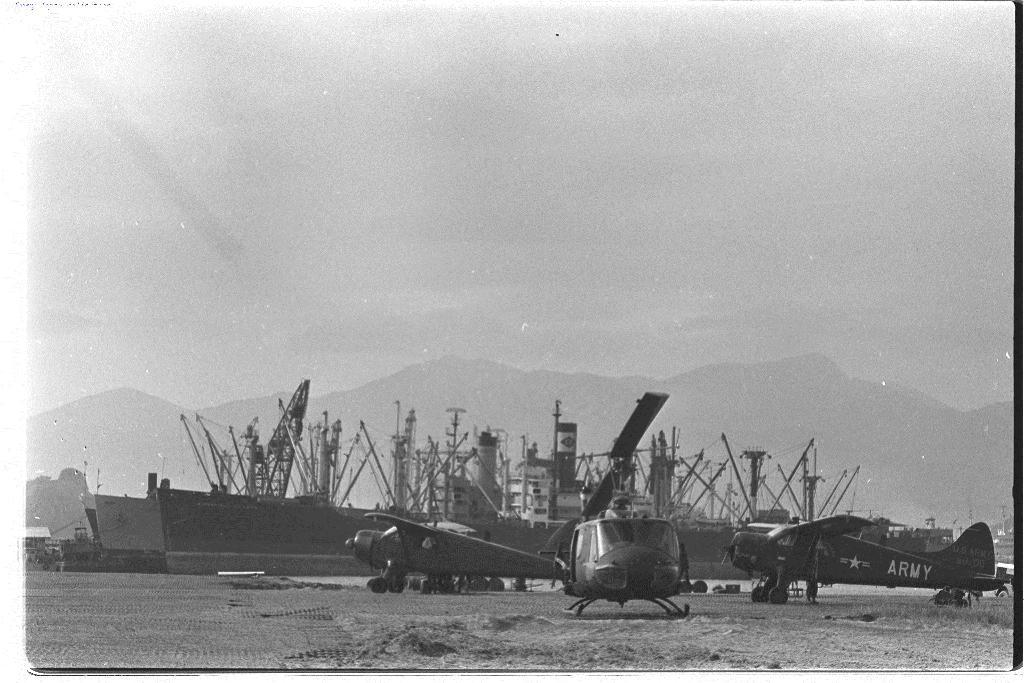What types of vehicles are present in the image? There are aircrafts and ships in the image. What geographical feature can be seen in the image? There are mountains in the image. How was the image created? The image is an edited picture. What is visible at the top of the image? The sky is visible at the top of the image. What type of plantation can be seen in the image? There is no plantation present in the image; it features aircrafts, ships, mountains, and an edited sky. 